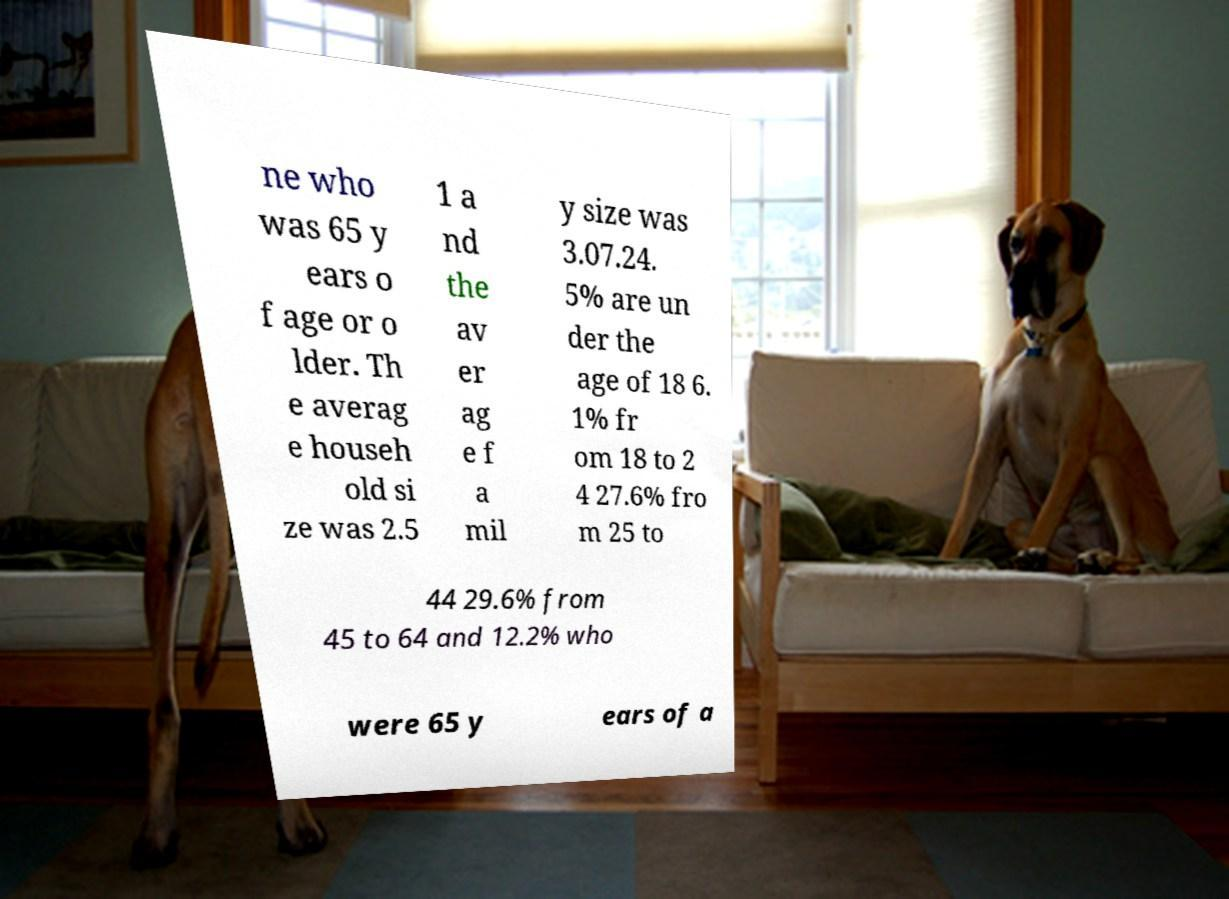Can you accurately transcribe the text from the provided image for me? ne who was 65 y ears o f age or o lder. Th e averag e househ old si ze was 2.5 1 a nd the av er ag e f a mil y size was 3.07.24. 5% are un der the age of 18 6. 1% fr om 18 to 2 4 27.6% fro m 25 to 44 29.6% from 45 to 64 and 12.2% who were 65 y ears of a 